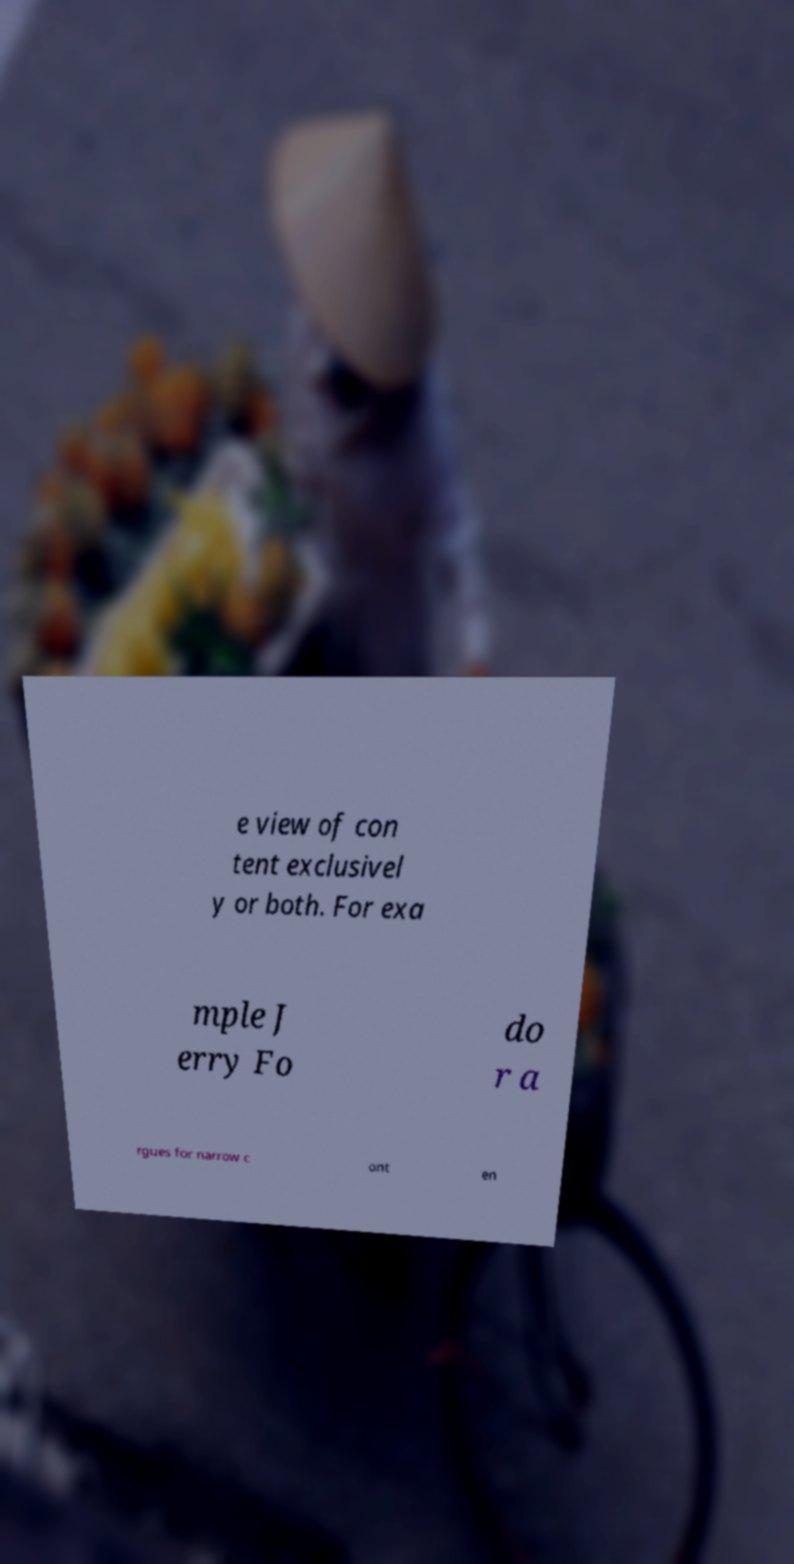There's text embedded in this image that I need extracted. Can you transcribe it verbatim? e view of con tent exclusivel y or both. For exa mple J erry Fo do r a rgues for narrow c ont en 